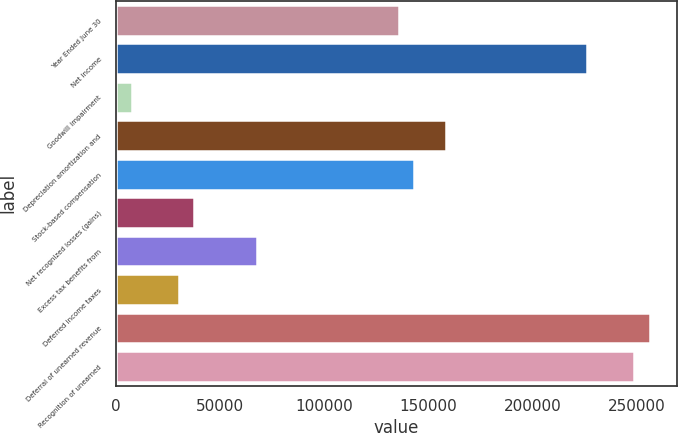<chart> <loc_0><loc_0><loc_500><loc_500><bar_chart><fcel>Year Ended June 30<fcel>Net income<fcel>Goodwill impairment<fcel>Depreciation amortization and<fcel>Stock-based compensation<fcel>Net recognized losses (gains)<fcel>Excess tax benefits from<fcel>Deferred income taxes<fcel>Deferral of unearned revenue<fcel>Recognition of unearned<nl><fcel>135711<fcel>226183<fcel>7541.69<fcel>158329<fcel>143250<fcel>37699.2<fcel>67856.6<fcel>30159.8<fcel>256341<fcel>248802<nl></chart> 